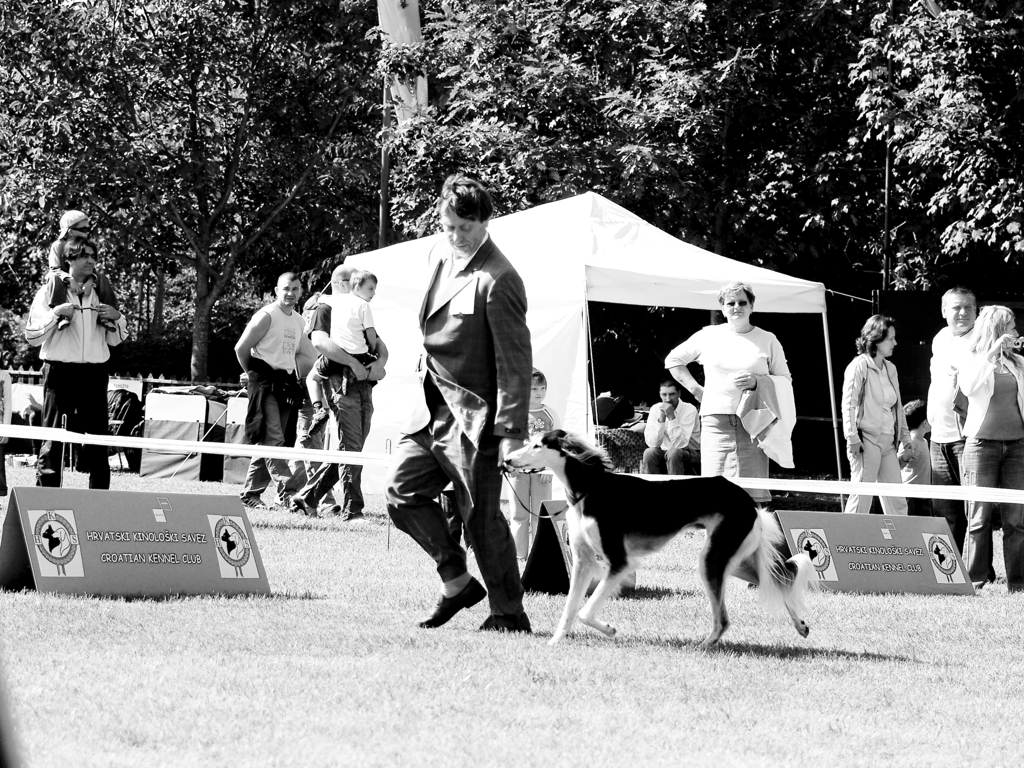Are the edges in this image distinct and sharp? The photograph displayed is in black and white, featuring what appears to be an outdoor event, possibly a dog show. Despite the black and white filter, it is possible to discern that the edges within this image are relatively sharp, as shown by the clear lines and distinctions between the dog, the handler, and the background crowd. However, there are areas with motion blur, particularly around the moving dog, which introduce some softness to the otherwise crisp scene. 